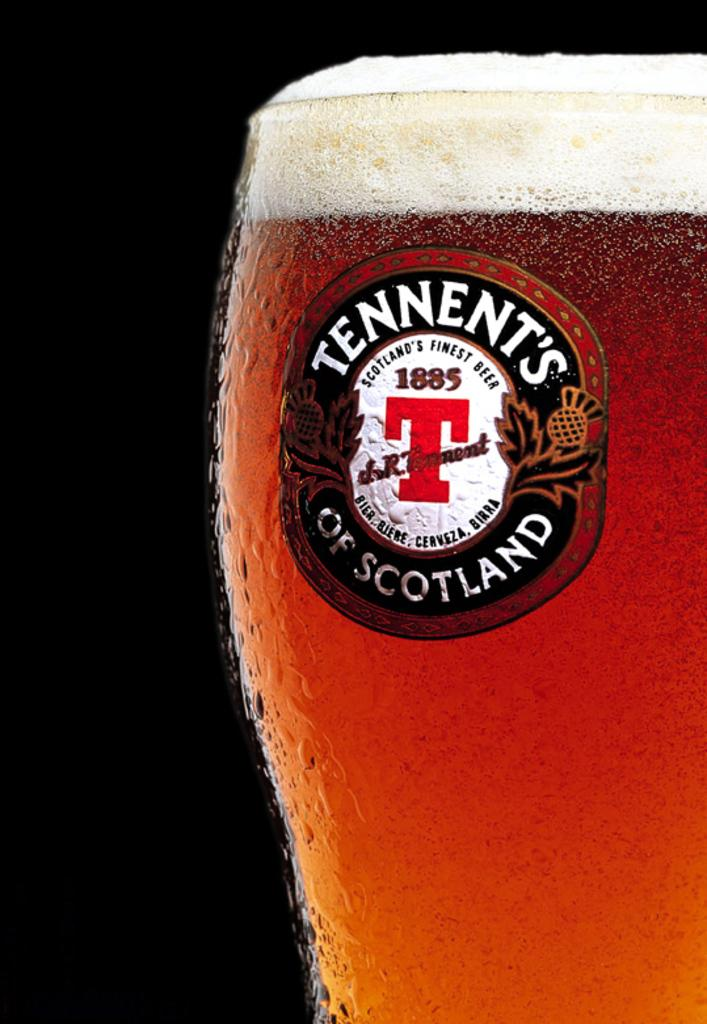<image>
Relay a brief, clear account of the picture shown. Full cup of beer with the symbol Tennent's of Scotland on it. 